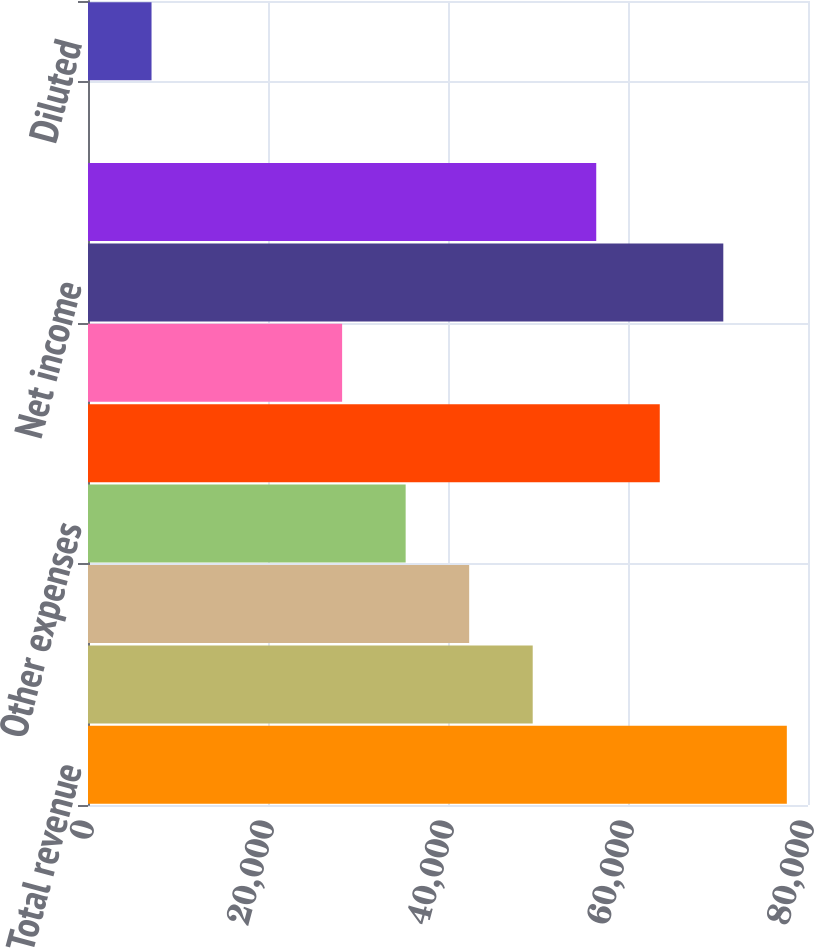Convert chart. <chart><loc_0><loc_0><loc_500><loc_500><bar_chart><fcel>Total revenue<fcel>Depreciation and amortization<fcel>Interest expense<fcel>Other expenses<fcel>Income from continuing<fcel>Income from discontinued<fcel>Net income<fcel>common stockholders<fcel>Basic<fcel>Diluted<nl><fcel>77647.9<fcel>49412.4<fcel>42353.5<fcel>35294.7<fcel>63530.1<fcel>28235.8<fcel>70589<fcel>56471.3<fcel>0.31<fcel>7059.18<nl></chart> 